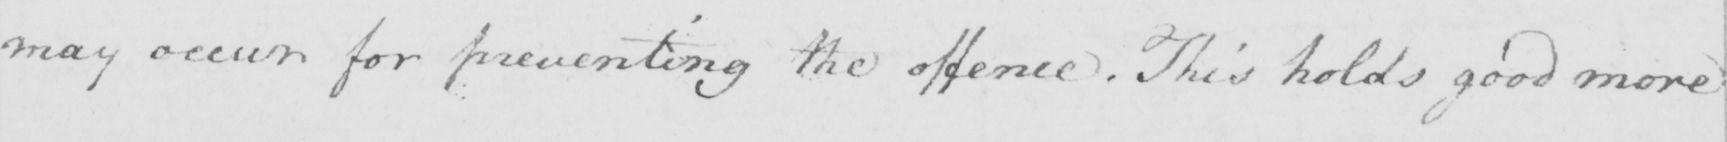Can you read and transcribe this handwriting? may occur for preventing the offence . This holds good more 